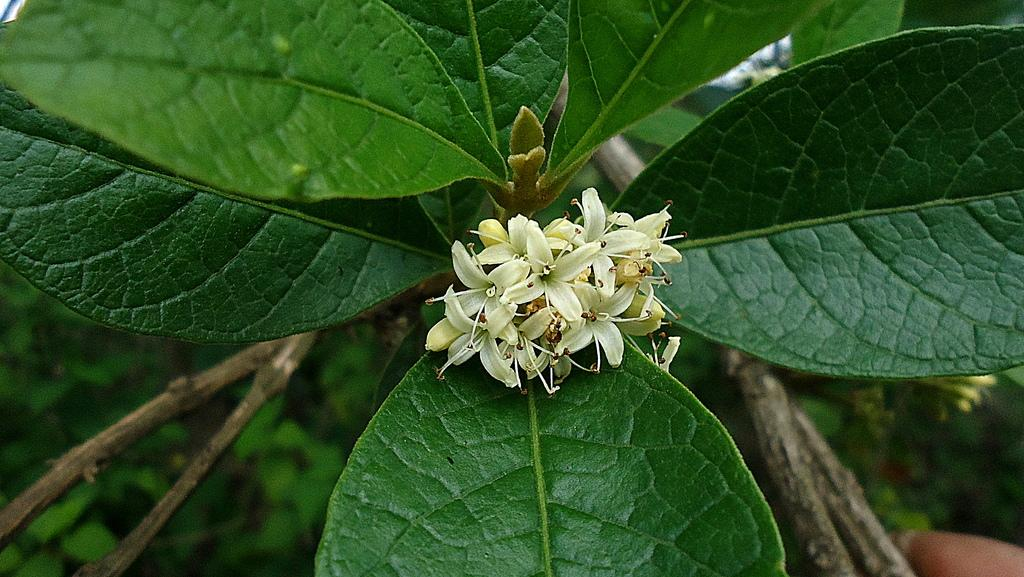What can be seen in the foreground of the picture? There are flowers, leaves, and stems in the foreground of the picture. What type of vegetation is present in the foreground? The foreground features flowers, leaves, and stems. What can be seen in the background of the picture? There is greenery and stems in the background of the picture. How many types of vegetation can be seen in the picture? There are at least three types of vegetation visible: flowers, leaves, and stems. What type of writing or arithmetic problem is depicted on the leaves in the image? There is no writing or arithmetic problem present on the leaves in the image; they are simply part of the vegetation. What type of test can be seen being conducted on the flowers in the image? There is no test being conducted on the flowers in the image; they are simply part of the natural scene. 